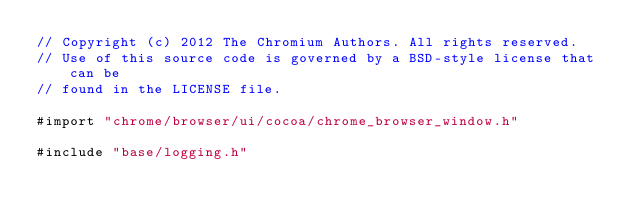<code> <loc_0><loc_0><loc_500><loc_500><_ObjectiveC_>// Copyright (c) 2012 The Chromium Authors. All rights reserved.
// Use of this source code is governed by a BSD-style license that can be
// found in the LICENSE file.

#import "chrome/browser/ui/cocoa/chrome_browser_window.h"

#include "base/logging.h"</code> 